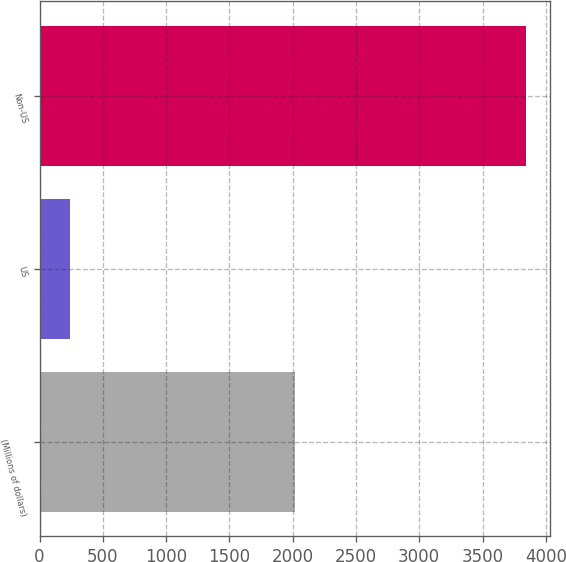Convert chart. <chart><loc_0><loc_0><loc_500><loc_500><bar_chart><fcel>(Millions of dollars)<fcel>US<fcel>Non-US<nl><fcel>2017<fcel>240<fcel>3842<nl></chart> 